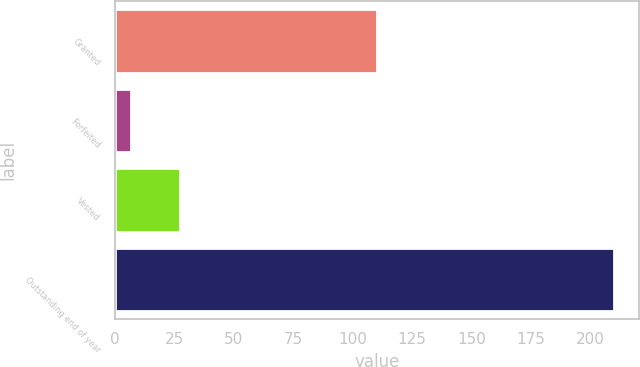<chart> <loc_0><loc_0><loc_500><loc_500><bar_chart><fcel>Granted<fcel>Forfeited<fcel>Vested<fcel>Outstanding end of year<nl><fcel>110<fcel>7<fcel>27.3<fcel>210<nl></chart> 